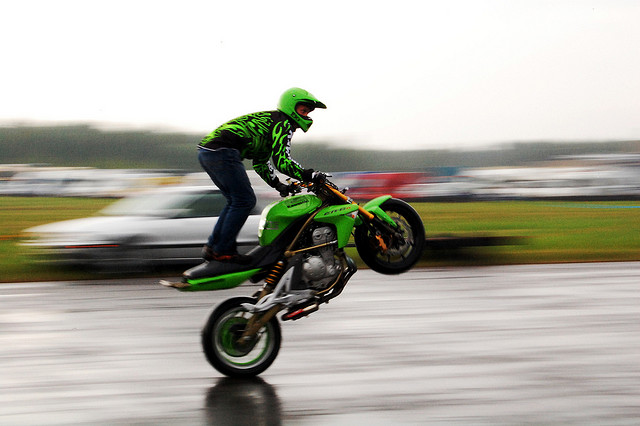Are there any obvious noise spots? Upon reviewing the image, option C is generally accurate as there are no prominent or distracting noise spots disturbing the clarity of the image. However, some minor graininess may appear upon closer inspection, although it does not significantly detract from the overall visual quality. 